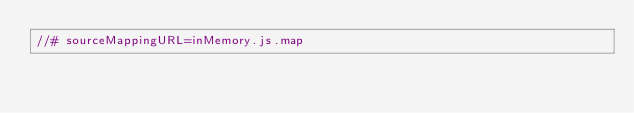Convert code to text. <code><loc_0><loc_0><loc_500><loc_500><_JavaScript_>//# sourceMappingURL=inMemory.js.map</code> 